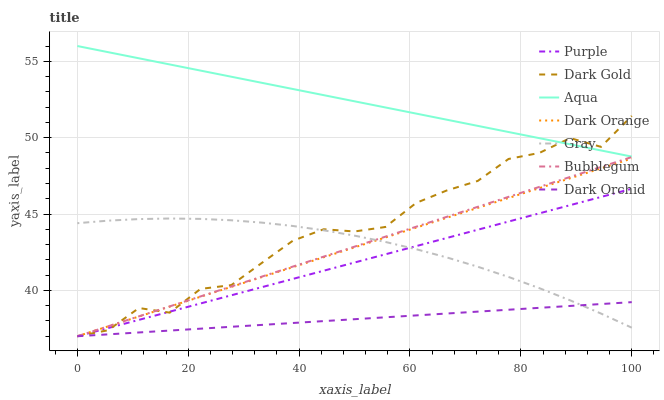Does Dark Orchid have the minimum area under the curve?
Answer yes or no. Yes. Does Aqua have the maximum area under the curve?
Answer yes or no. Yes. Does Gray have the minimum area under the curve?
Answer yes or no. No. Does Gray have the maximum area under the curve?
Answer yes or no. No. Is Dark Orange the smoothest?
Answer yes or no. Yes. Is Dark Gold the roughest?
Answer yes or no. Yes. Is Gray the smoothest?
Answer yes or no. No. Is Gray the roughest?
Answer yes or no. No. Does Dark Orange have the lowest value?
Answer yes or no. Yes. Does Gray have the lowest value?
Answer yes or no. No. Does Aqua have the highest value?
Answer yes or no. Yes. Does Gray have the highest value?
Answer yes or no. No. Is Dark Orchid less than Aqua?
Answer yes or no. Yes. Is Aqua greater than Bubblegum?
Answer yes or no. Yes. Does Purple intersect Dark Gold?
Answer yes or no. Yes. Is Purple less than Dark Gold?
Answer yes or no. No. Is Purple greater than Dark Gold?
Answer yes or no. No. Does Dark Orchid intersect Aqua?
Answer yes or no. No. 